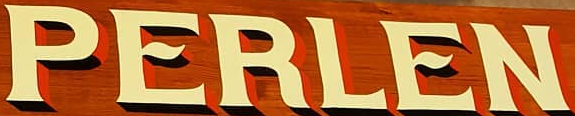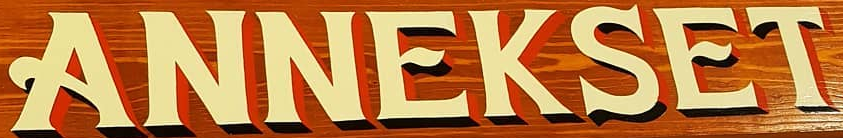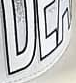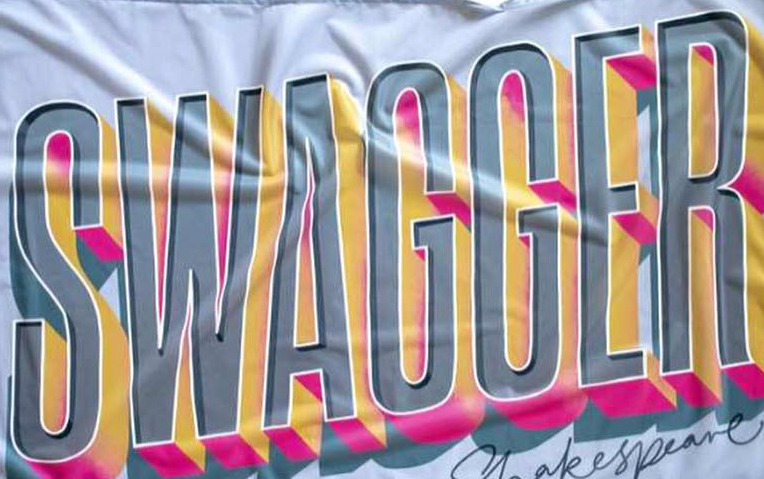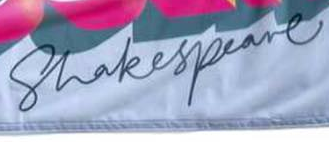Transcribe the words shown in these images in order, separated by a semicolon. PERLEN; ANNEKSET; ###; SWAGGER; Shakespeare 